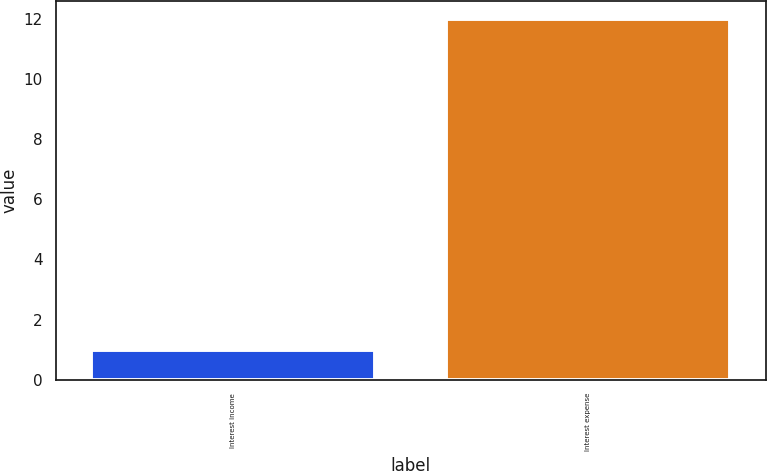Convert chart. <chart><loc_0><loc_0><loc_500><loc_500><bar_chart><fcel>Interest income<fcel>Interest expense<nl><fcel>1<fcel>12<nl></chart> 